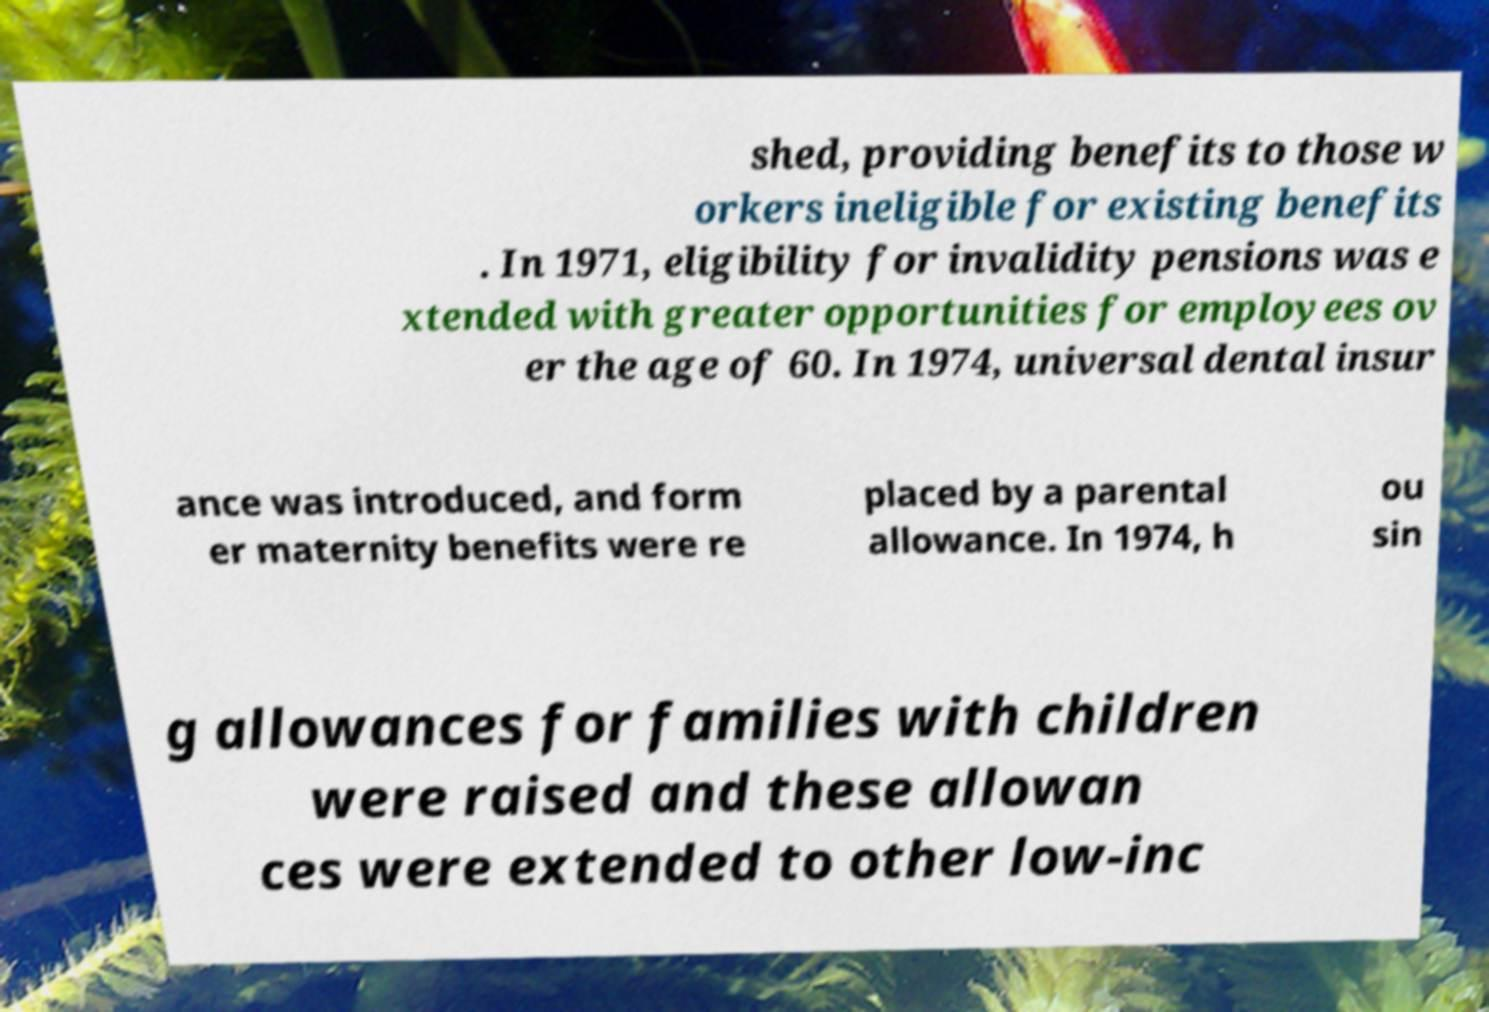Could you extract and type out the text from this image? shed, providing benefits to those w orkers ineligible for existing benefits . In 1971, eligibility for invalidity pensions was e xtended with greater opportunities for employees ov er the age of 60. In 1974, universal dental insur ance was introduced, and form er maternity benefits were re placed by a parental allowance. In 1974, h ou sin g allowances for families with children were raised and these allowan ces were extended to other low-inc 